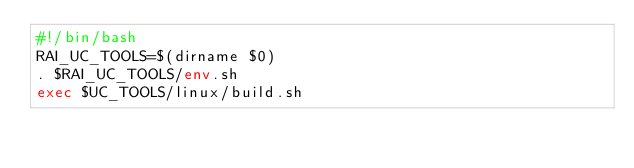<code> <loc_0><loc_0><loc_500><loc_500><_Bash_>#!/bin/bash
RAI_UC_TOOLS=$(dirname $0)
. $RAI_UC_TOOLS/env.sh
exec $UC_TOOLS/linux/build.sh
</code> 